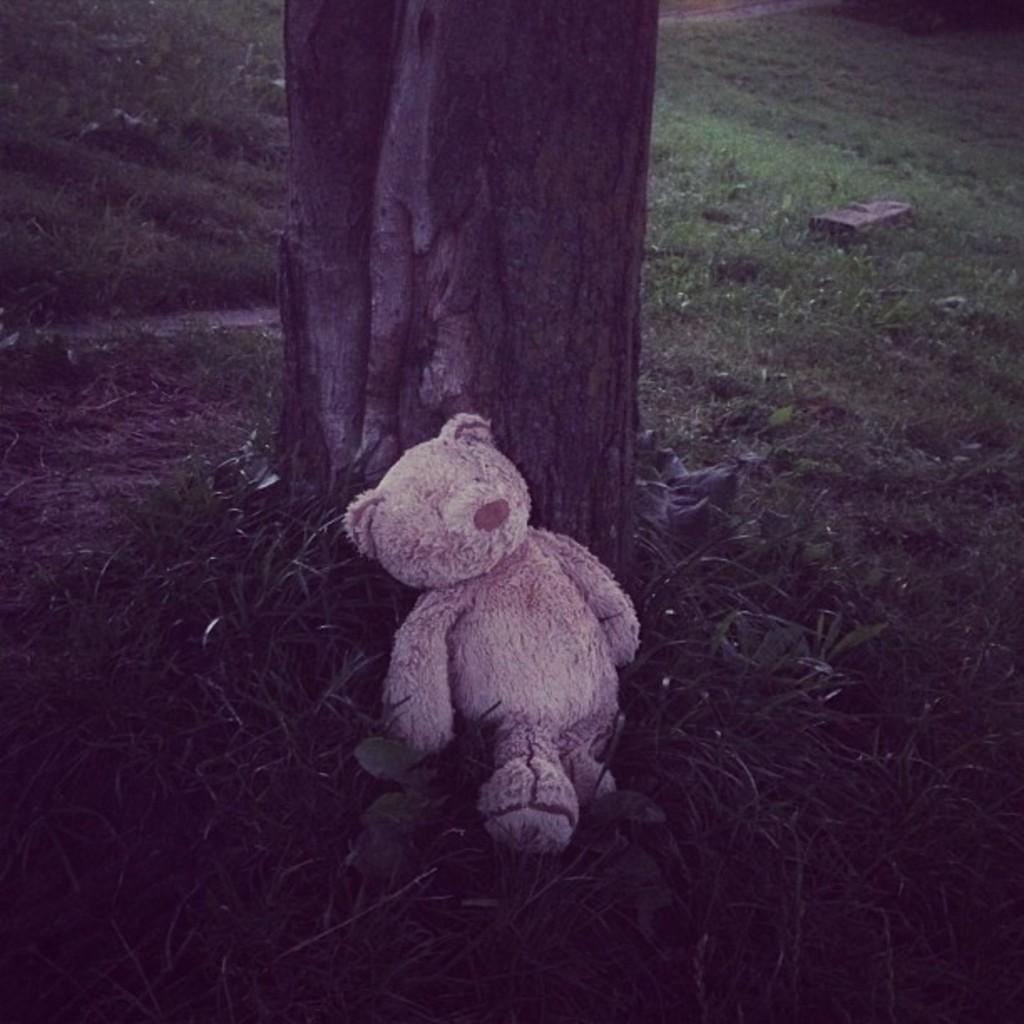Could you give a brief overview of what you see in this image? This image is taken outdoors. In the background there is a ground with grass on it. In the middle of the image there is a tree and there is a teddy bear on the ground. 